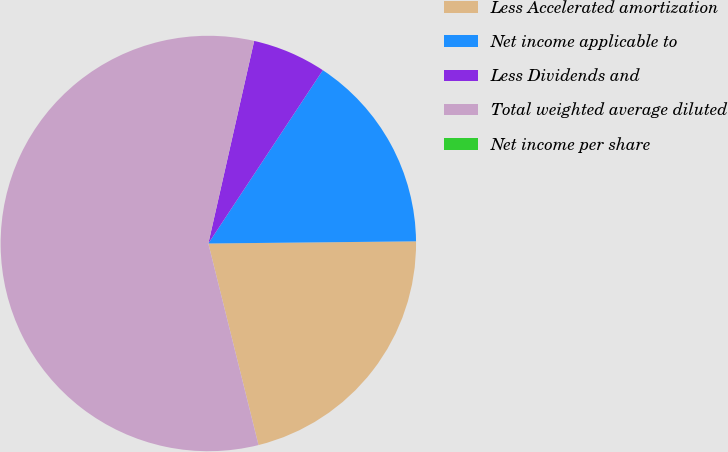Convert chart to OTSL. <chart><loc_0><loc_0><loc_500><loc_500><pie_chart><fcel>Less Accelerated amortization<fcel>Net income applicable to<fcel>Less Dividends and<fcel>Total weighted average diluted<fcel>Net income per share<nl><fcel>21.28%<fcel>15.54%<fcel>5.75%<fcel>57.42%<fcel>0.0%<nl></chart> 